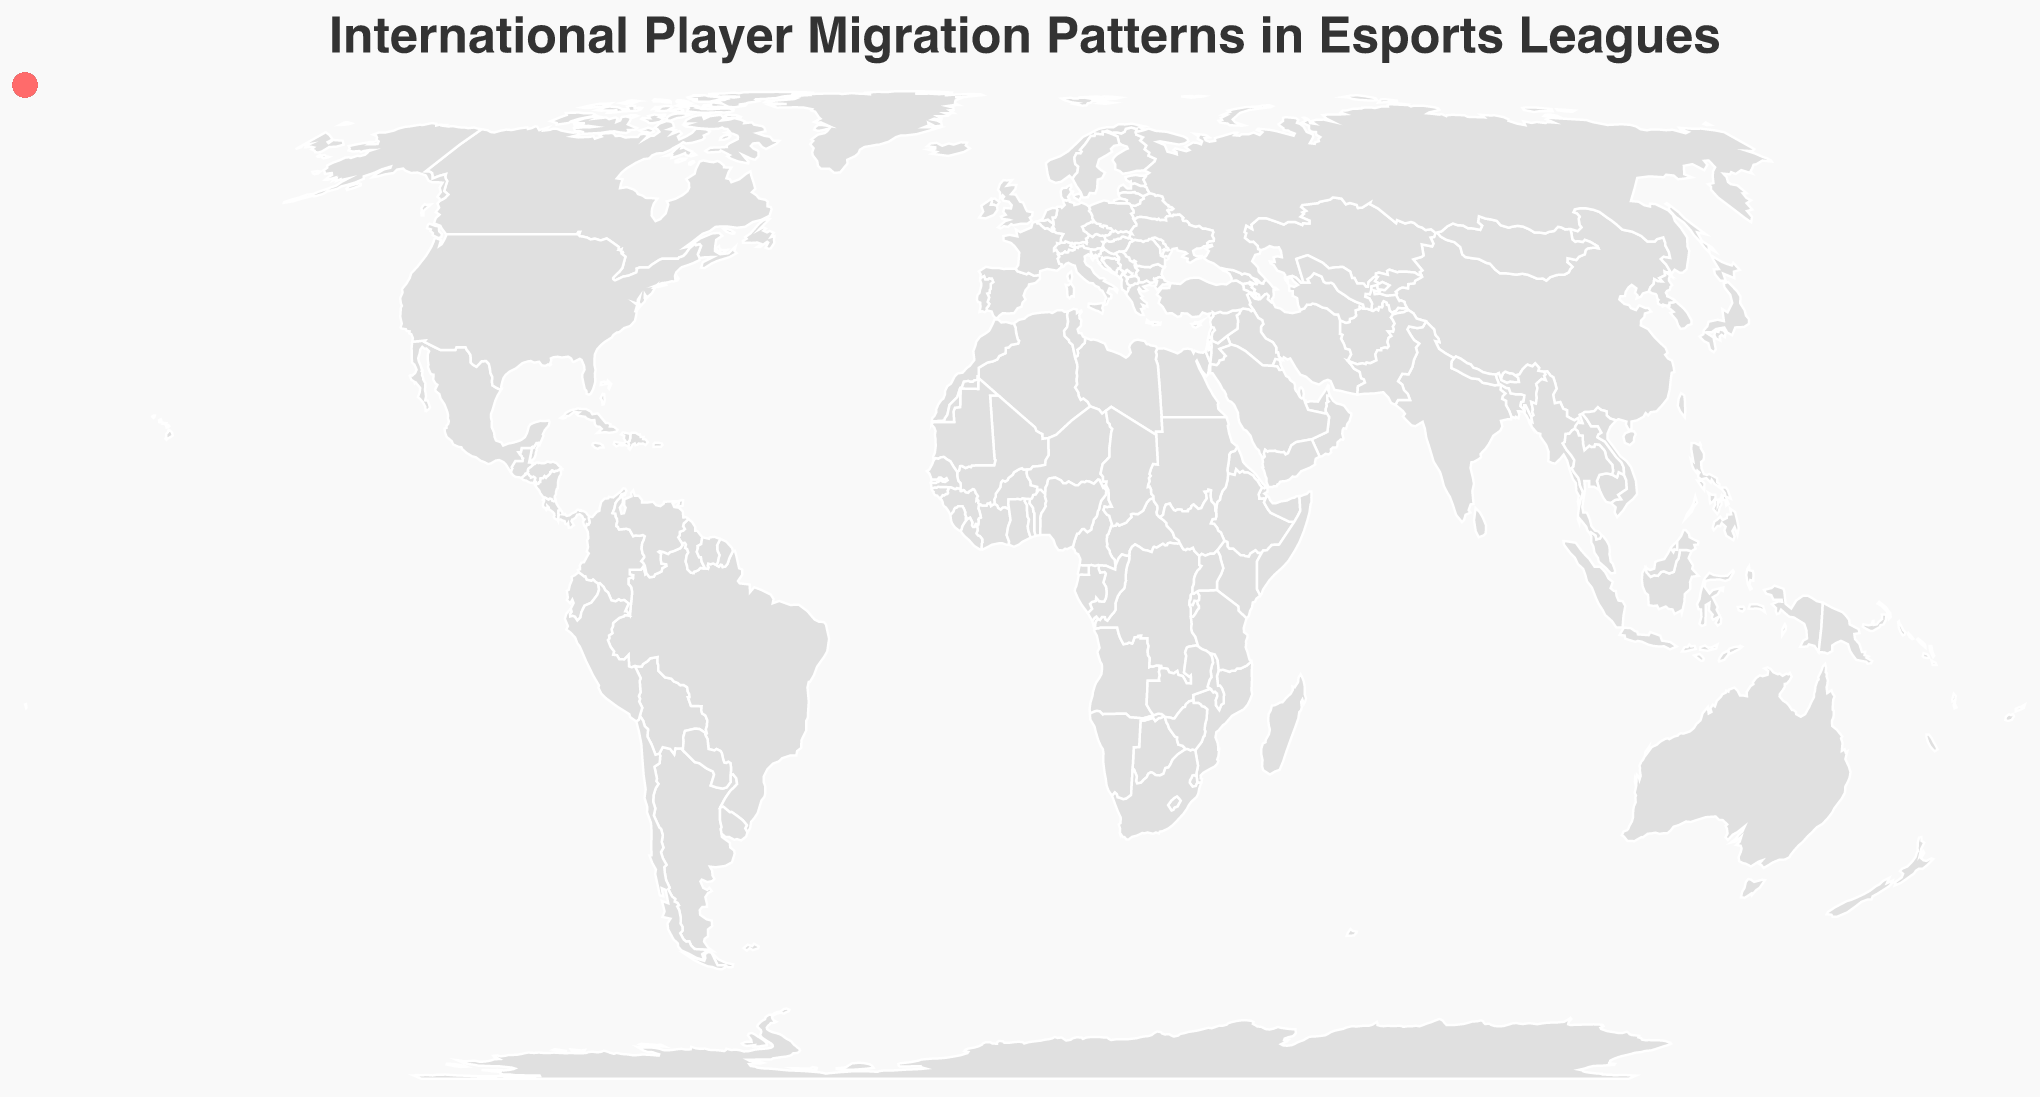Who is migrating to the United States in 2023? The plot shows lines connecting the origin and destination countries. By checking these lines, we find that Faker from South Korea and Ninja from the United States are migrating to the United States.
Answer: Faker and Ninja Which player had the longest migration distance? By observing the lines on the map, the longest distance appears to be between Denmark and Malaysia by N0tail.
Answer: N0tail What are the most common origin countries? By counting the occurrences of origin countries in the plot, the United States appears most frequently, with multiple players starting from there.
Answer: United States How many player migrations occurred in 2022? The tooltip for each migration provides the year. By counting the occurrences of 2022, we see migrations for s1mple, Crimsix, ZywOo, and Bugha.
Answer: 4 Compare the number of League of Legends player migrations to those for Counter-Strike: Global Offensive. League of Legends has migrations by Faker and Uzi, while Counter-Strike: Global Offensive has migrations by s1mple and ZywOo.
Answer: Equal (2 each) Which players migrated to Germany? The plot shows lines pointing to Germany and examining them reveals that s1mple and Bugha migrated to Germany.
Answer: s1mple and Bugha What game had the latest migration in 2023? By looking at migrations in 2023 from the plot and tooltip, League of Legends (Faker) and Fortnite (Ninja) have latest migrations.
Answer: League of Legends and Fortnite What is the most frequent migration destination? By counting the occurrences of destination countries in the plot, the United States appears most frequently, with multiple players migrating there.
Answer: United States What is the shortest migration distance? The shortest distance appears to be the migration from the United States to Canada by Crimsix, as these countries are neighbors.
Answer: Crimsix Which migration involves a player from Pakistan? Checking the origin tooltip reveals that SumaiL migrated from Pakistan.
Answer: SumaiL 